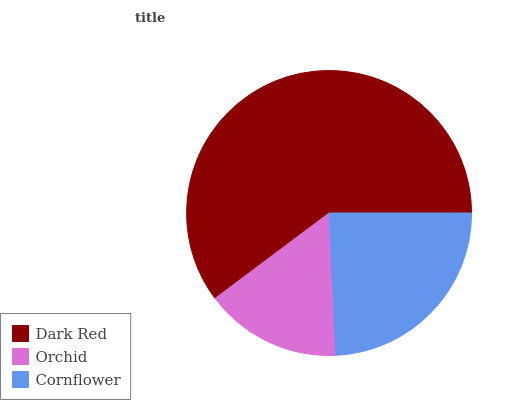Is Orchid the minimum?
Answer yes or no. Yes. Is Dark Red the maximum?
Answer yes or no. Yes. Is Cornflower the minimum?
Answer yes or no. No. Is Cornflower the maximum?
Answer yes or no. No. Is Cornflower greater than Orchid?
Answer yes or no. Yes. Is Orchid less than Cornflower?
Answer yes or no. Yes. Is Orchid greater than Cornflower?
Answer yes or no. No. Is Cornflower less than Orchid?
Answer yes or no. No. Is Cornflower the high median?
Answer yes or no. Yes. Is Cornflower the low median?
Answer yes or no. Yes. Is Orchid the high median?
Answer yes or no. No. Is Dark Red the low median?
Answer yes or no. No. 